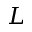Convert formula to latex. <formula><loc_0><loc_0><loc_500><loc_500>L</formula> 